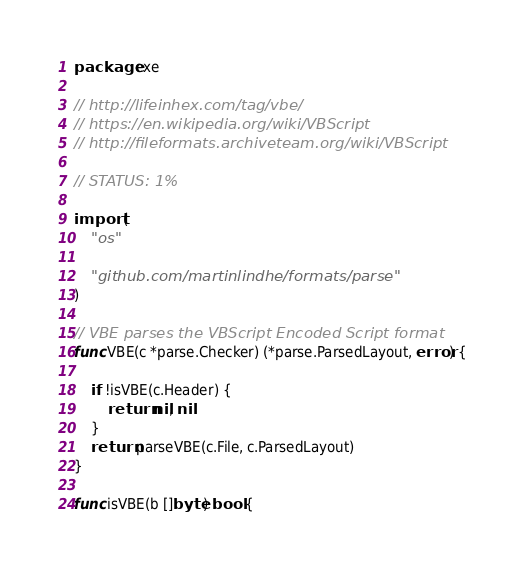<code> <loc_0><loc_0><loc_500><loc_500><_Go_>package exe

// http://lifeinhex.com/tag/vbe/
// https://en.wikipedia.org/wiki/VBScript
// http://fileformats.archiveteam.org/wiki/VBScript

// STATUS: 1%

import (
	"os"

	"github.com/martinlindhe/formats/parse"
)

// VBE parses the VBScript Encoded Script format
func VBE(c *parse.Checker) (*parse.ParsedLayout, error) {

	if !isVBE(c.Header) {
		return nil, nil
	}
	return parseVBE(c.File, c.ParsedLayout)
}

func isVBE(b []byte) bool {
</code> 